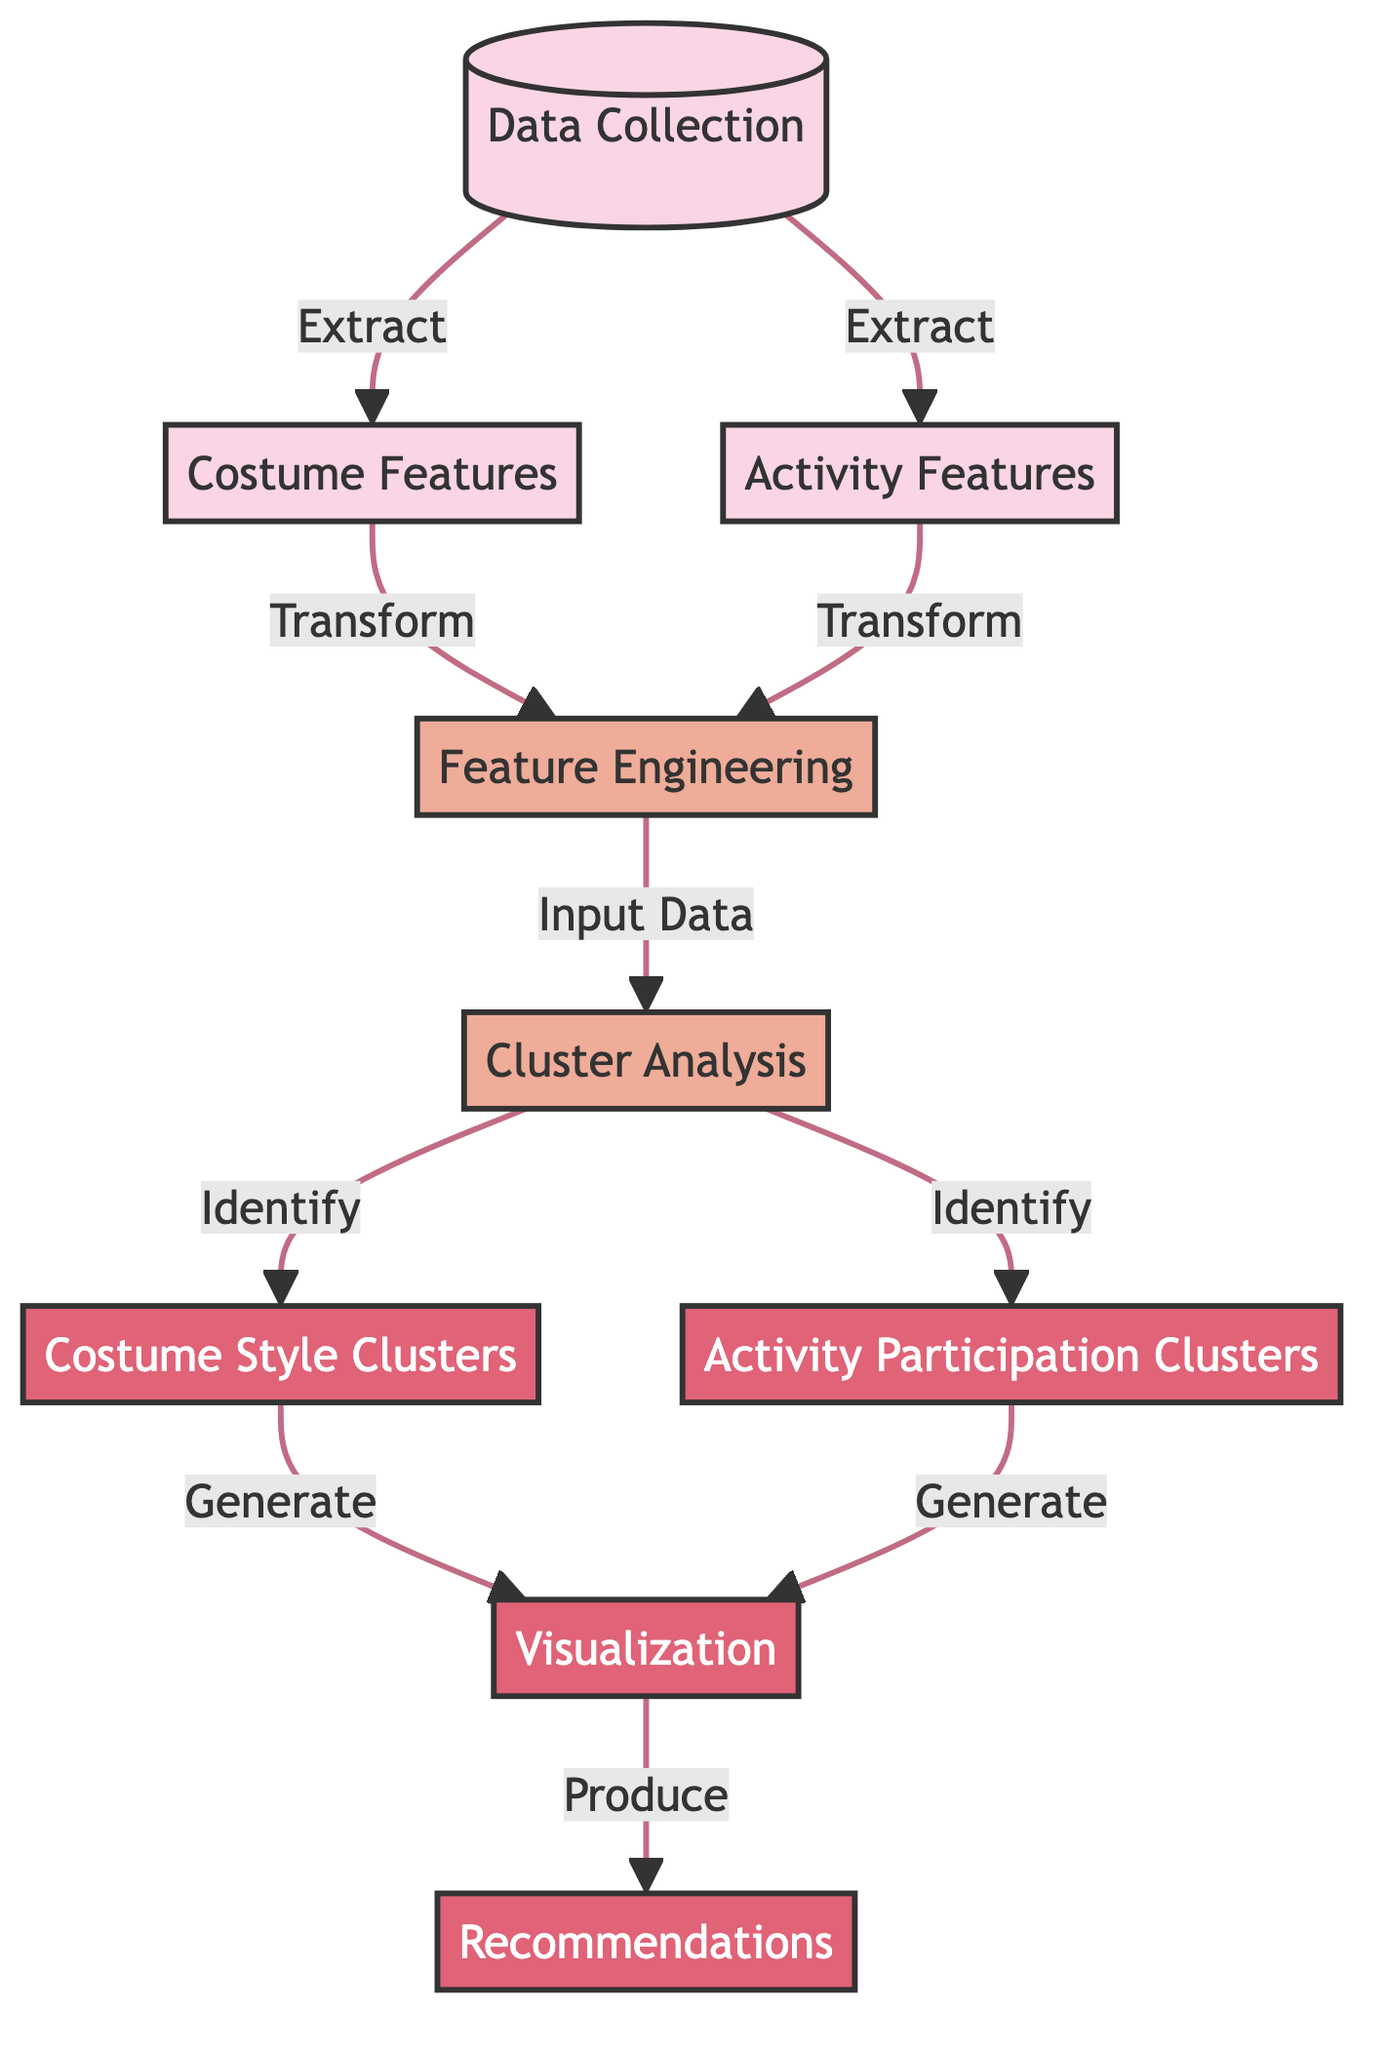What are the two main types of features collected? The diagram indicates two main collections from "Data Collection": "Costume Features" and "Activity Features". These features involve aspects of attendees' costumes and the activities they participate in.
Answer: Costume Features and Activity Features How many output clusters are identified from the "Cluster Analysis"? The diagram shows two outputs generated from "Cluster Analysis": "Costume Style Clusters" and "Activity Participation Clusters". Thus, there are two distinct clusters identified.
Answer: Two What process follows after collecting "Costume Features"? After collecting "Costume Features", the next step in the diagram is "Feature Engineering". This process involves transforming the costume-related data for further analysis.
Answer: Feature Engineering What is the final output generated in this diagram? The final output produced in the diagram is "Recommendations", which are generated based on the visualizations of the clusters identified earlier in the process.
Answer: Recommendations Which node generates "Costume Style Clusters"? The node labeled "Cluster Analysis" is responsible for identifying and generating the "Costume Style Clusters". This node serves as the critical point for cluster identification based on features.
Answer: Cluster Analysis How do "Costume Features" and "Activity Features" relate to "Feature Engineering"? Both "Costume Features" and "Activity Features" are transformed through "Feature Engineering", serving as inputs to this process. Thus, they are direct contributors to feature transformation for analysis.
Answer: They are inputs to Feature Engineering What type of diagram is displayed here? This diagram represents a Machine Learning workflow specifically focusing on clustering techniques used to categorize event attendees by their costume styles and activities.
Answer: Machine Learning Diagram What does the "Visualization" node produce? The "Visualization" node generates outputs that aid in interpreting the results of the clustering processes, ultimately leading to the final production of "Recommendations".
Answer: Recommendations 